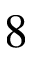<formula> <loc_0><loc_0><loc_500><loc_500>8</formula> 